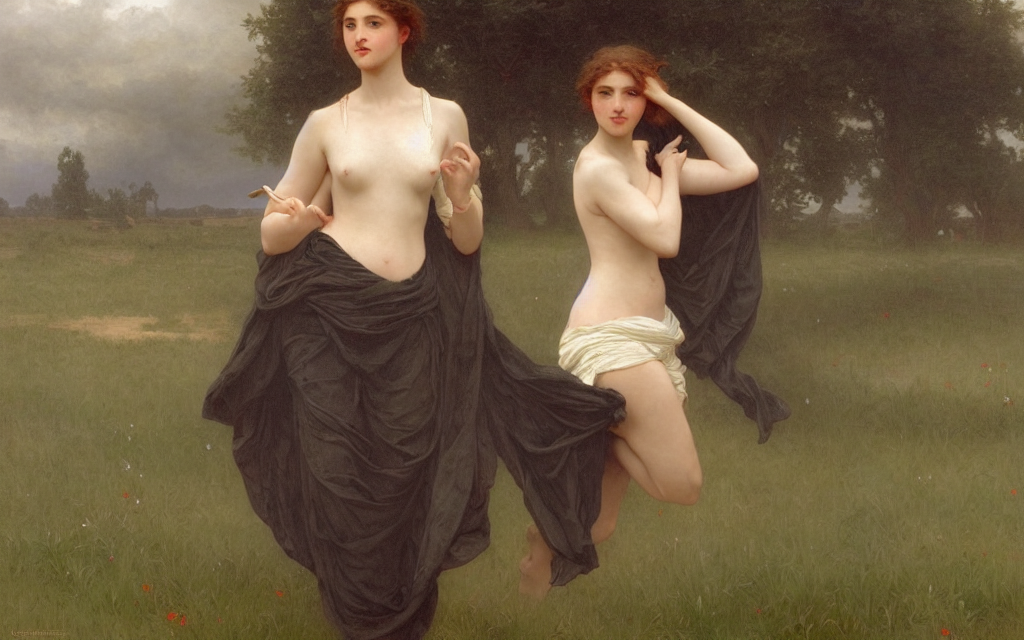Could you describe the mood or atmosphere portrayed in this image? There's a serene and somewhat mystic atmosphere portrayed. The soft lighting, muted colors of the landscape, and the cloudy sky create a calm, introspective mood, inviting the viewer to ponder upon the deeper meaning of the image. 